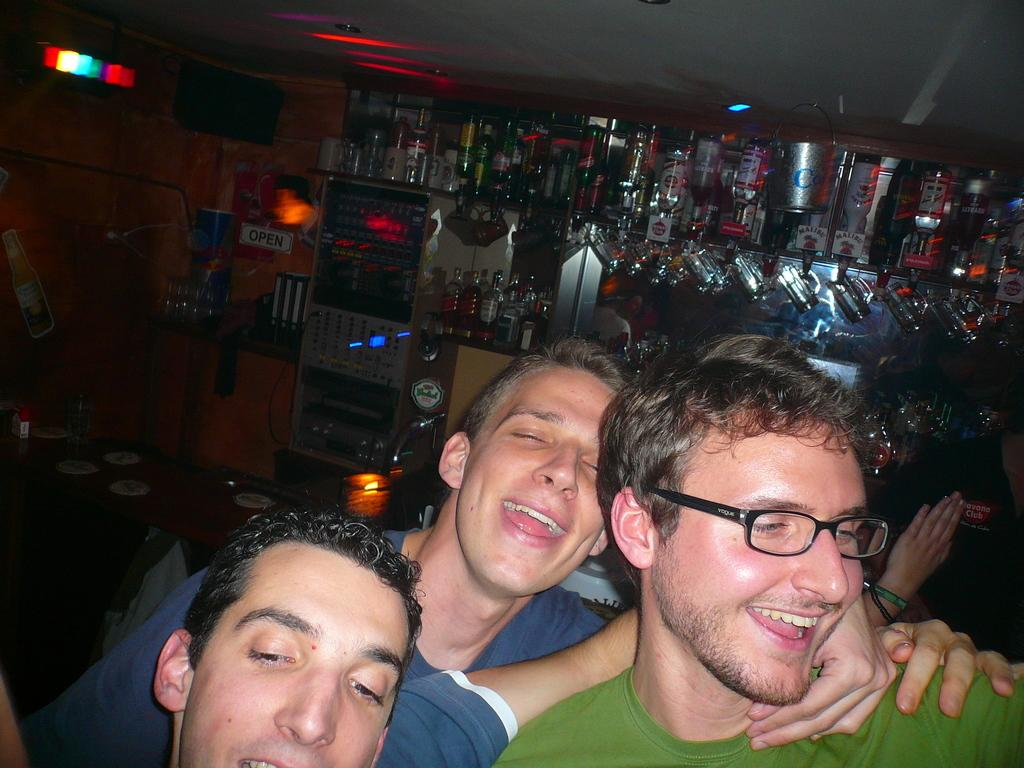How many people are in the image? There are three men in the image. What are the men doing in the image? The men are standing and smiling. What can be seen in the background of the image? There are bottles and a wall in the background of the image. What type of truck is parked next to the men in the image? There is no truck present in the image; it only features three men standing and smiling. 